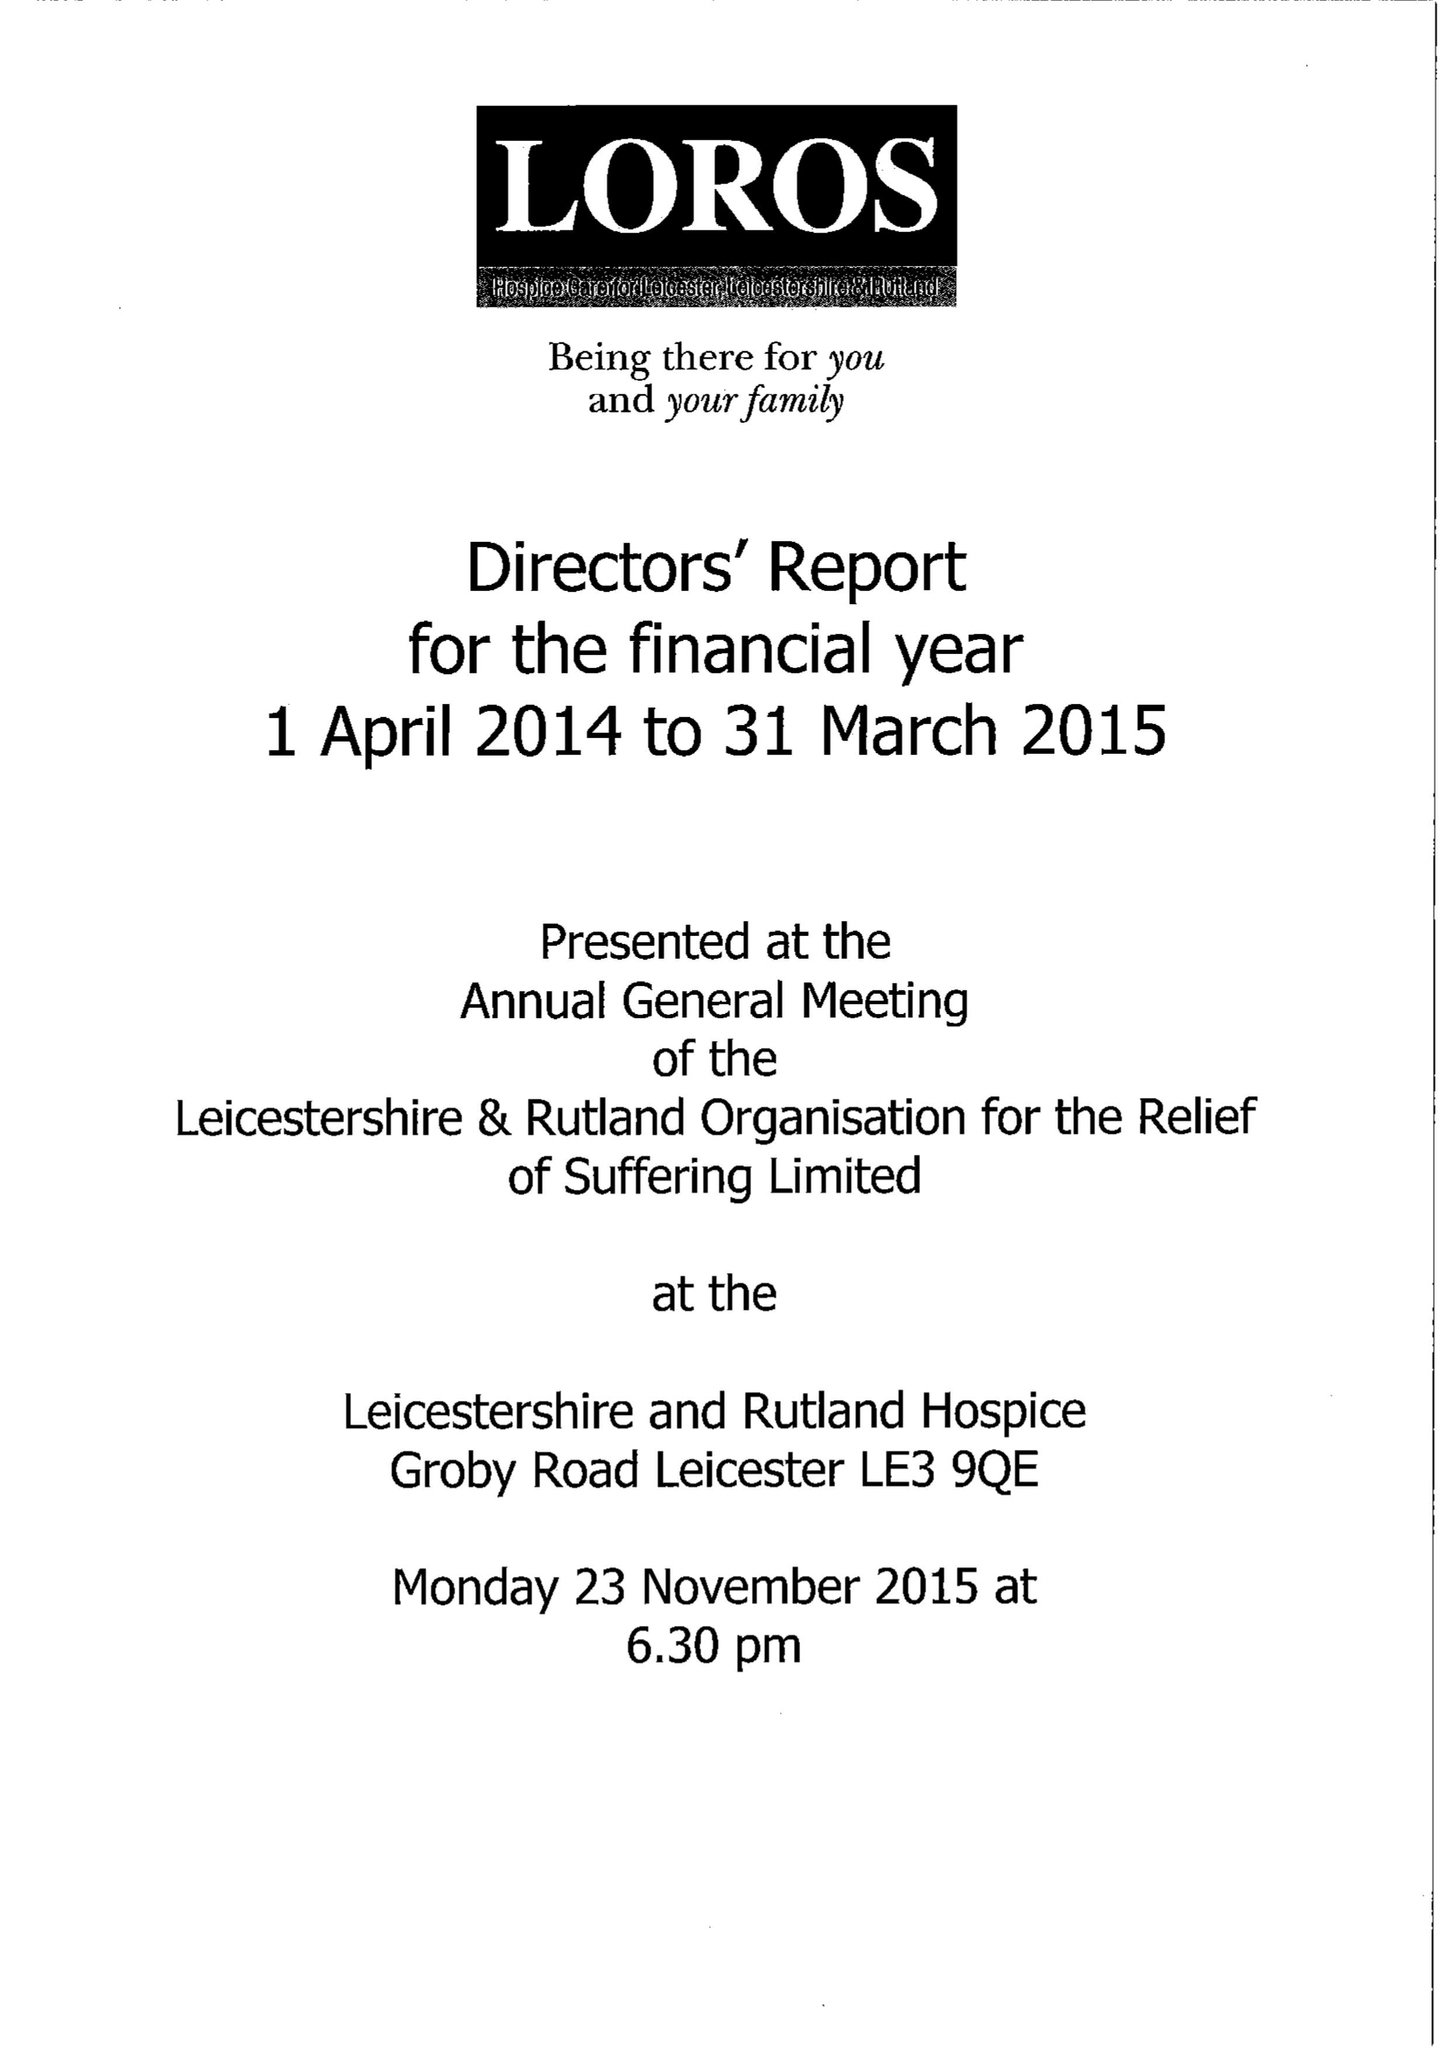What is the value for the charity_name?
Answer the question using a single word or phrase. Leicestershire and Rutland Organisation For The Relief Of Suffering Ltd. 